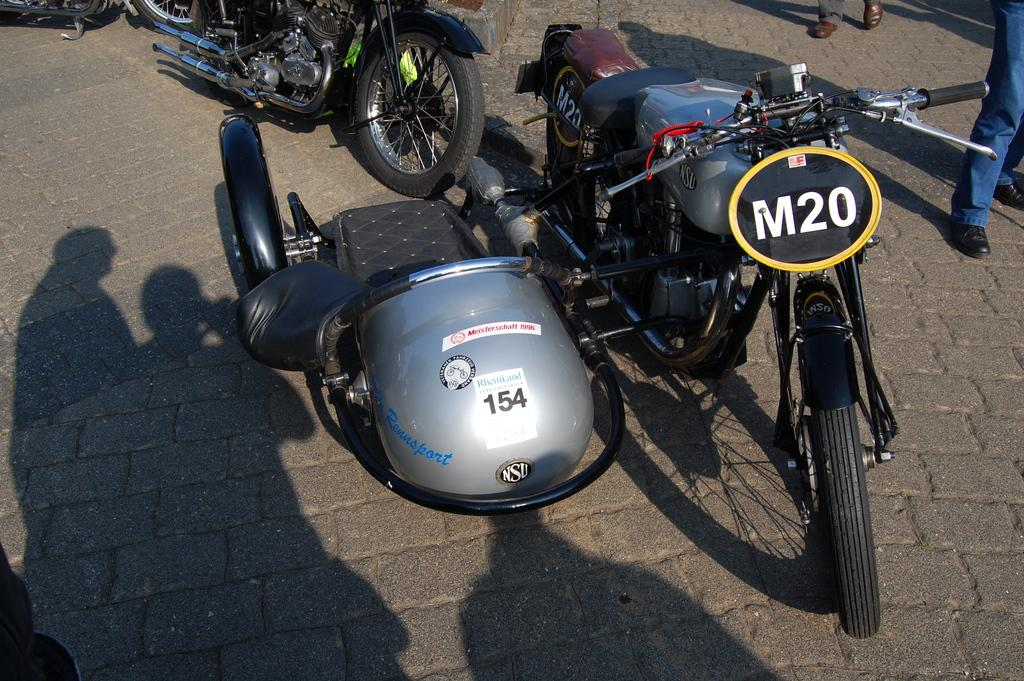What is present on the surface in the image? There are likes on the surface in the image. What can be observed in the image that indicates the presence of people? There are shadows of persons in the image, and the legs of persons are visible on the right side of the image. What is the temperature on the street in the image? There is no street present in the image, so it is not possible to determine the temperature. 